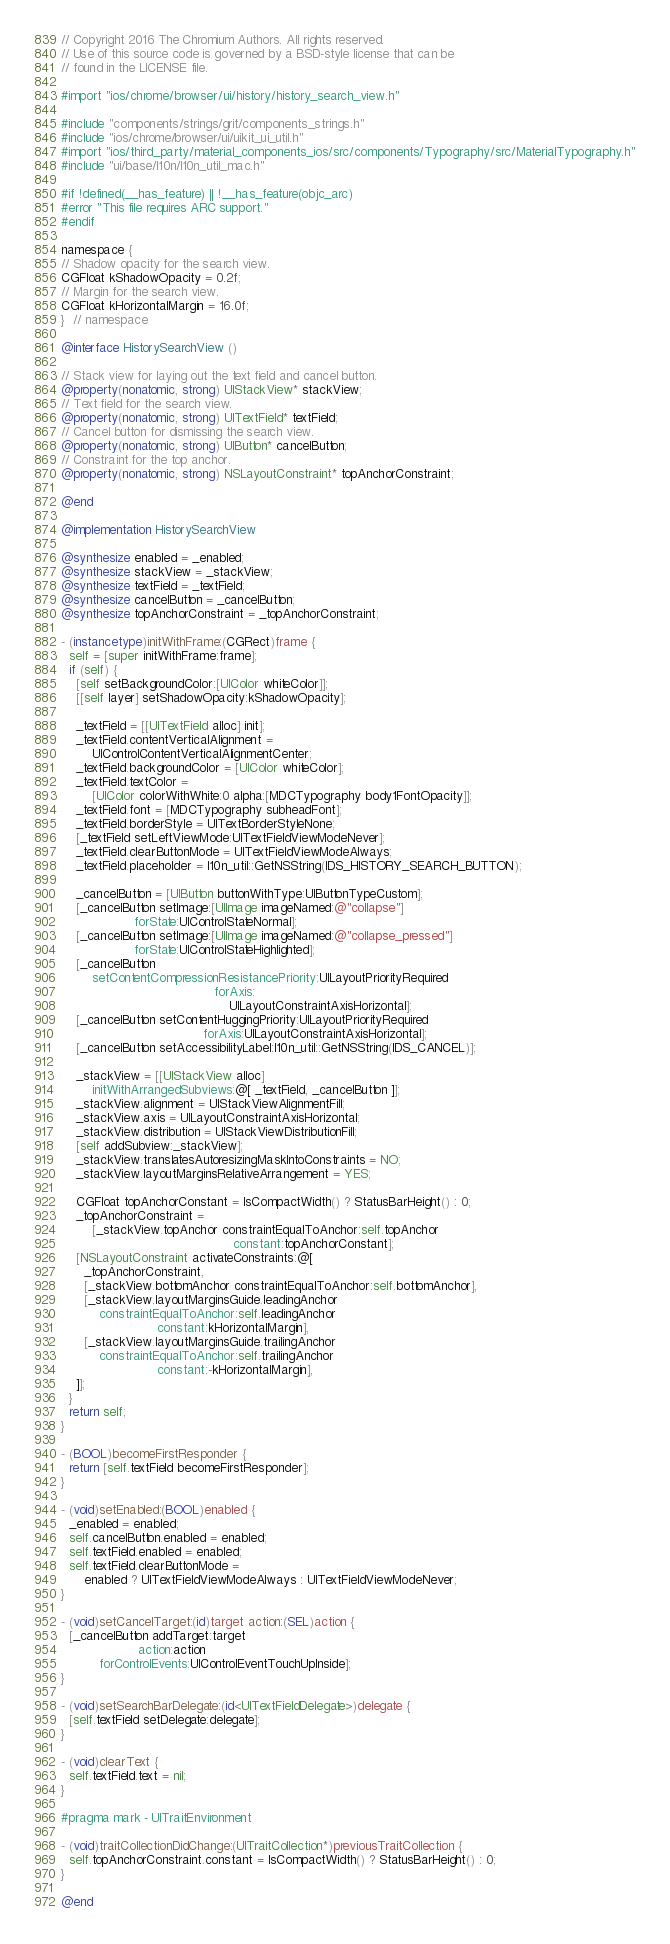<code> <loc_0><loc_0><loc_500><loc_500><_ObjectiveC_>// Copyright 2016 The Chromium Authors. All rights reserved.
// Use of this source code is governed by a BSD-style license that can be
// found in the LICENSE file.

#import "ios/chrome/browser/ui/history/history_search_view.h"

#include "components/strings/grit/components_strings.h"
#include "ios/chrome/browser/ui/uikit_ui_util.h"
#import "ios/third_party/material_components_ios/src/components/Typography/src/MaterialTypography.h"
#include "ui/base/l10n/l10n_util_mac.h"

#if !defined(__has_feature) || !__has_feature(objc_arc)
#error "This file requires ARC support."
#endif

namespace {
// Shadow opacity for the search view.
CGFloat kShadowOpacity = 0.2f;
// Margin for the search view.
CGFloat kHorizontalMargin = 16.0f;
}  // namespace

@interface HistorySearchView ()

// Stack view for laying out the text field and cancel button.
@property(nonatomic, strong) UIStackView* stackView;
// Text field for the search view.
@property(nonatomic, strong) UITextField* textField;
// Cancel button for dismissing the search view.
@property(nonatomic, strong) UIButton* cancelButton;
// Constraint for the top anchor.
@property(nonatomic, strong) NSLayoutConstraint* topAnchorConstraint;

@end

@implementation HistorySearchView

@synthesize enabled = _enabled;
@synthesize stackView = _stackView;
@synthesize textField = _textField;
@synthesize cancelButton = _cancelButton;
@synthesize topAnchorConstraint = _topAnchorConstraint;

- (instancetype)initWithFrame:(CGRect)frame {
  self = [super initWithFrame:frame];
  if (self) {
    [self setBackgroundColor:[UIColor whiteColor]];
    [[self layer] setShadowOpacity:kShadowOpacity];

    _textField = [[UITextField alloc] init];
    _textField.contentVerticalAlignment =
        UIControlContentVerticalAlignmentCenter;
    _textField.backgroundColor = [UIColor whiteColor];
    _textField.textColor =
        [UIColor colorWithWhite:0 alpha:[MDCTypography body1FontOpacity]];
    _textField.font = [MDCTypography subheadFont];
    _textField.borderStyle = UITextBorderStyleNone;
    [_textField setLeftViewMode:UITextFieldViewModeNever];
    _textField.clearButtonMode = UITextFieldViewModeAlways;
    _textField.placeholder = l10n_util::GetNSString(IDS_HISTORY_SEARCH_BUTTON);

    _cancelButton = [UIButton buttonWithType:UIButtonTypeCustom];
    [_cancelButton setImage:[UIImage imageNamed:@"collapse"]
                   forState:UIControlStateNormal];
    [_cancelButton setImage:[UIImage imageNamed:@"collapse_pressed"]
                   forState:UIControlStateHighlighted];
    [_cancelButton
        setContentCompressionResistancePriority:UILayoutPriorityRequired
                                        forAxis:
                                            UILayoutConstraintAxisHorizontal];
    [_cancelButton setContentHuggingPriority:UILayoutPriorityRequired
                                     forAxis:UILayoutConstraintAxisHorizontal];
    [_cancelButton setAccessibilityLabel:l10n_util::GetNSString(IDS_CANCEL)];

    _stackView = [[UIStackView alloc]
        initWithArrangedSubviews:@[ _textField, _cancelButton ]];
    _stackView.alignment = UIStackViewAlignmentFill;
    _stackView.axis = UILayoutConstraintAxisHorizontal;
    _stackView.distribution = UIStackViewDistributionFill;
    [self addSubview:_stackView];
    _stackView.translatesAutoresizingMaskIntoConstraints = NO;
    _stackView.layoutMarginsRelativeArrangement = YES;

    CGFloat topAnchorConstant = IsCompactWidth() ? StatusBarHeight() : 0;
    _topAnchorConstraint =
        [_stackView.topAnchor constraintEqualToAnchor:self.topAnchor
                                             constant:topAnchorConstant];
    [NSLayoutConstraint activateConstraints:@[
      _topAnchorConstraint,
      [_stackView.bottomAnchor constraintEqualToAnchor:self.bottomAnchor],
      [_stackView.layoutMarginsGuide.leadingAnchor
          constraintEqualToAnchor:self.leadingAnchor
                         constant:kHorizontalMargin],
      [_stackView.layoutMarginsGuide.trailingAnchor
          constraintEqualToAnchor:self.trailingAnchor
                         constant:-kHorizontalMargin],
    ]];
  }
  return self;
}

- (BOOL)becomeFirstResponder {
  return [self.textField becomeFirstResponder];
}

- (void)setEnabled:(BOOL)enabled {
  _enabled = enabled;
  self.cancelButton.enabled = enabled;
  self.textField.enabled = enabled;
  self.textField.clearButtonMode =
      enabled ? UITextFieldViewModeAlways : UITextFieldViewModeNever;
}

- (void)setCancelTarget:(id)target action:(SEL)action {
  [_cancelButton addTarget:target
                    action:action
          forControlEvents:UIControlEventTouchUpInside];
}

- (void)setSearchBarDelegate:(id<UITextFieldDelegate>)delegate {
  [self.textField setDelegate:delegate];
}

- (void)clearText {
  self.textField.text = nil;
}

#pragma mark - UITraitEnvironment

- (void)traitCollectionDidChange:(UITraitCollection*)previousTraitCollection {
  self.topAnchorConstraint.constant = IsCompactWidth() ? StatusBarHeight() : 0;
}

@end
</code> 